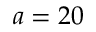<formula> <loc_0><loc_0><loc_500><loc_500>a = 2 0</formula> 